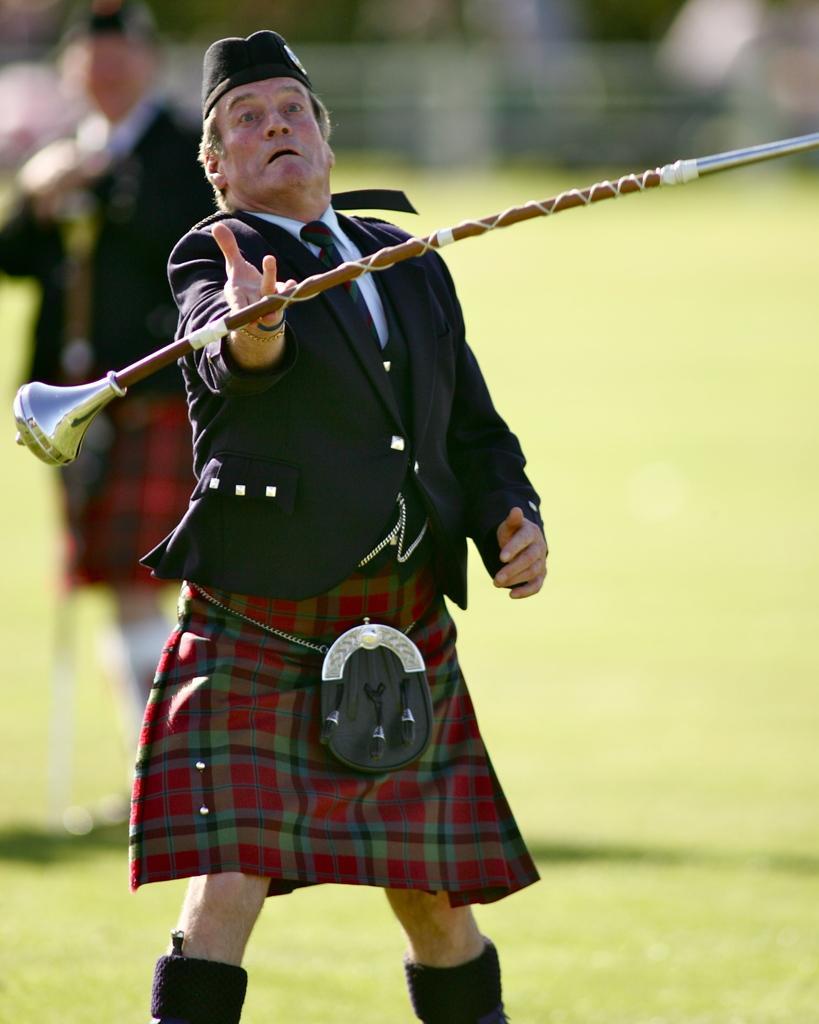Can you describe this image briefly? In this image, in the foreground I can see an old man holding a stick and on the left there is man standing. 